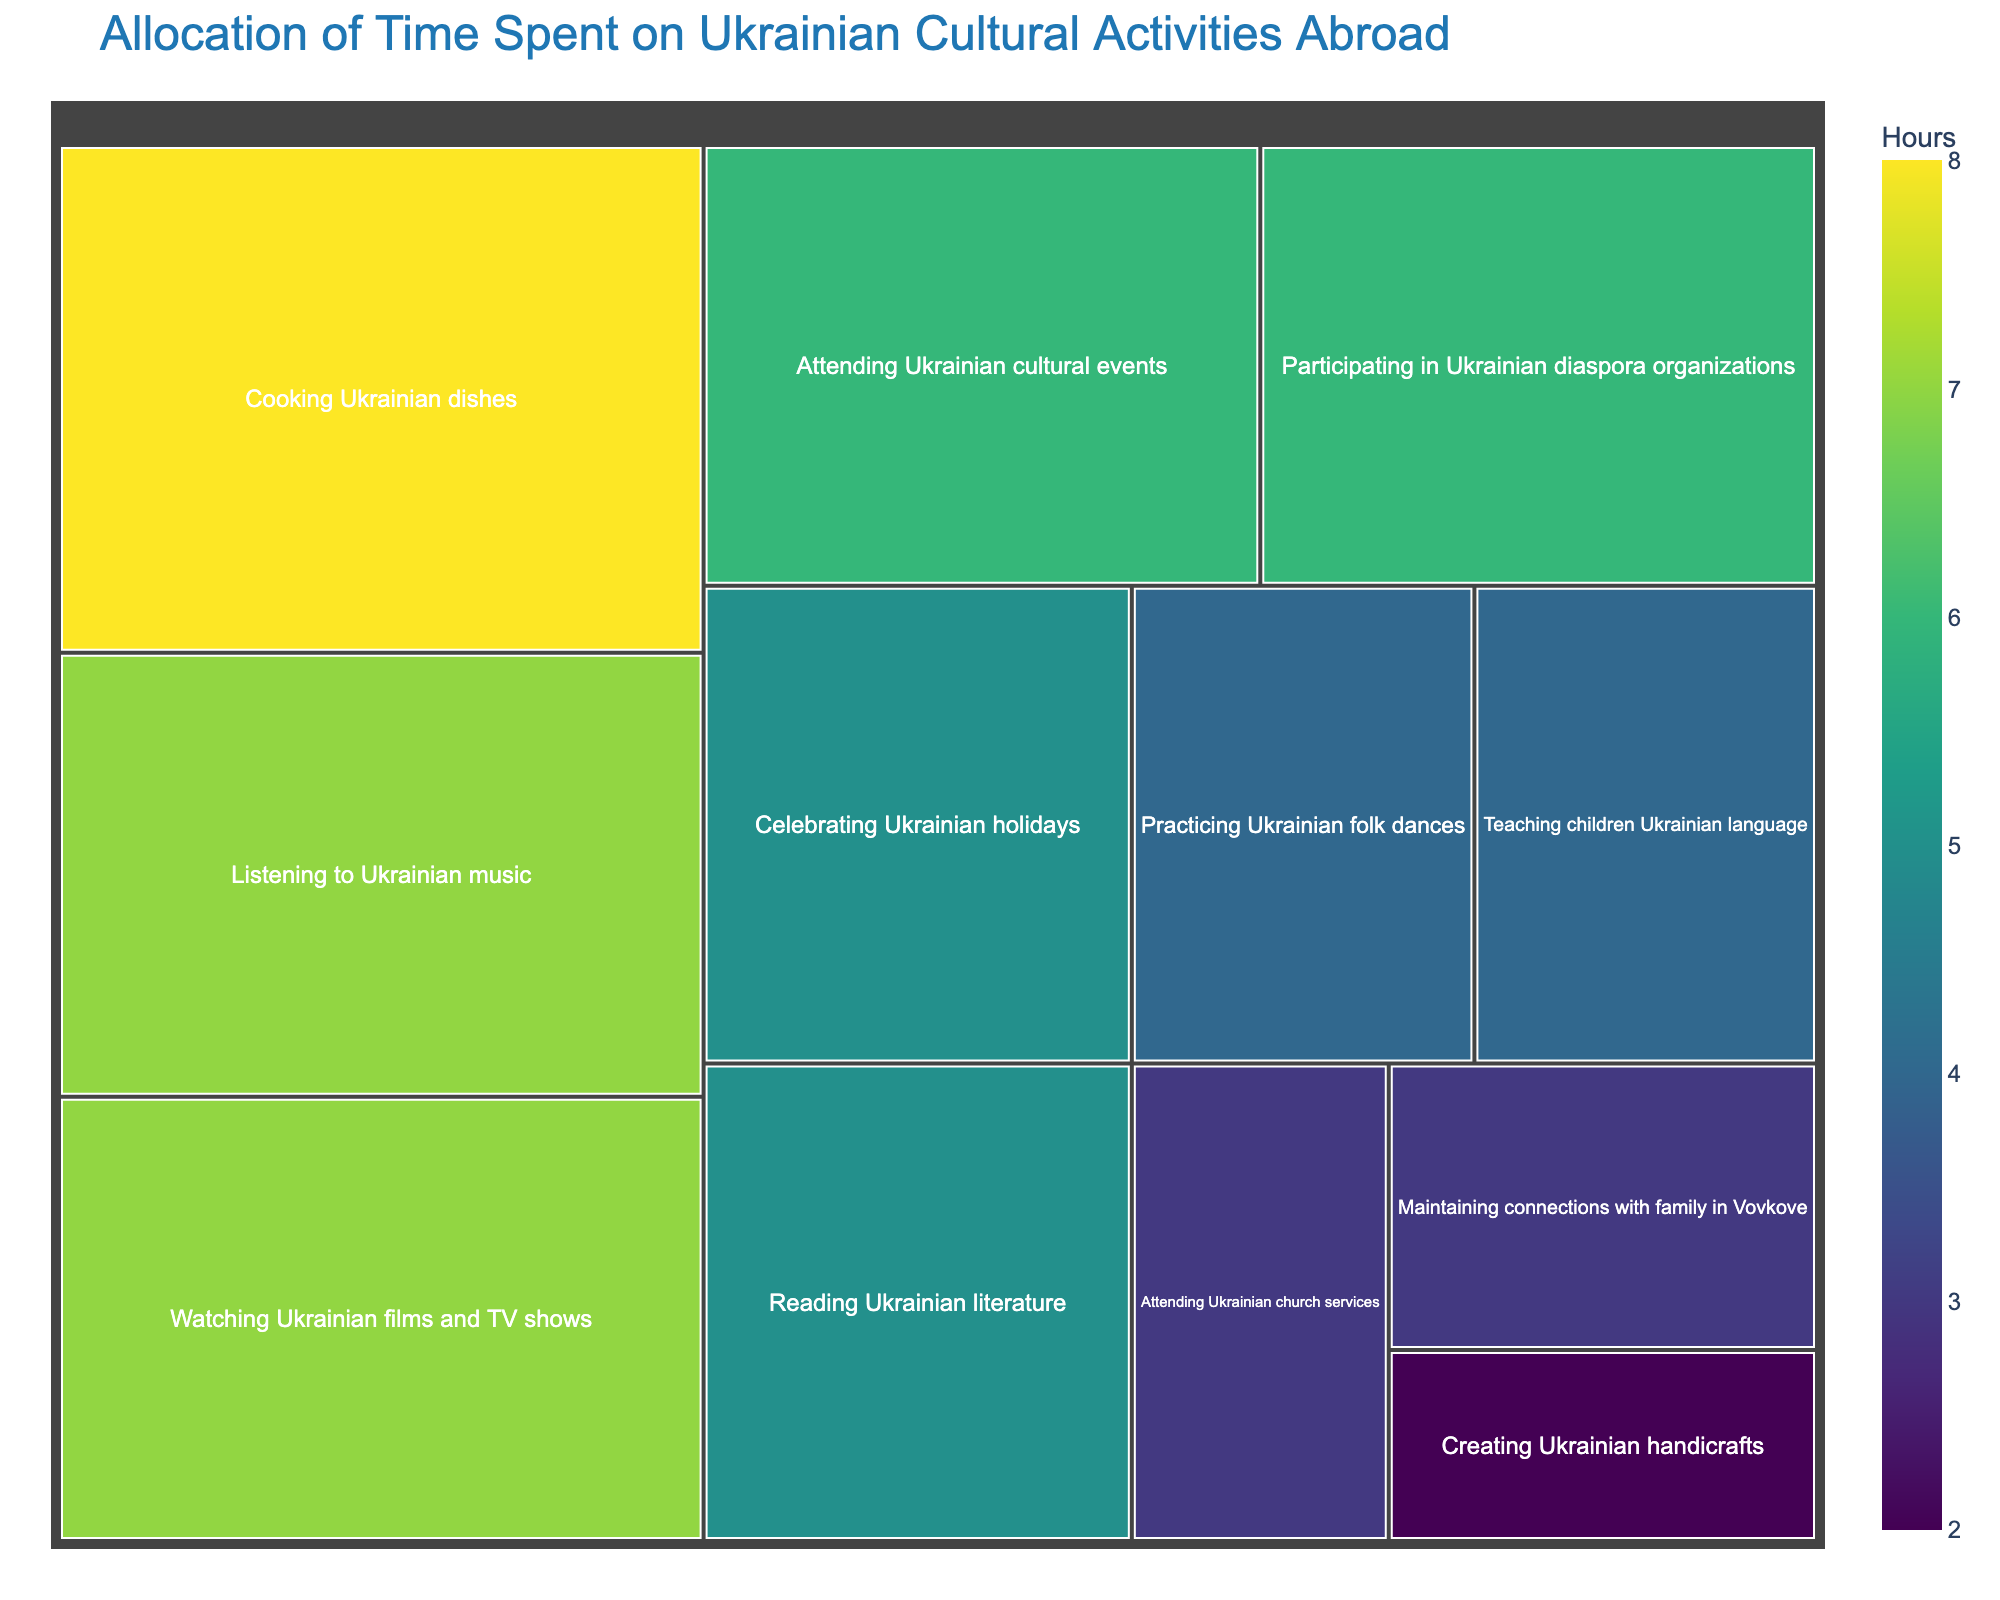What's the title of the figure? The title is usually displayed prominently at the top of the figure. In this treemap, it's labeled clearly.
Answer: Allocation of Time Spent on Ukrainian Cultural Activities Abroad Which activity consumes the most hours? To determine which activity consumes the most hours, look for the largest block in the treemap. The block with "Cooking Ukrainian dishes" is the largest, indicating 8 hours.
Answer: Cooking Ukrainian dishes What is the combined time spent on watching Ukrainian films and TV shows, and listening to Ukrainian music? Add the hours for "Watching Ukrainian films and TV shows" and "Listening to Ukrainian music." The values are 7 hours each. So, 7 + 7 = 14 hours.
Answer: 14 hours Which two activities have the same amount of allocated time? Identify blocks with identical sizes. "Attending Ukrainian cultural events" and "Participating in Ukrainian diaspora organizations" each have 6 hours.
Answer: Attending Ukrainian cultural events and Participating in Ukrainian diaspora organizations How many hours are allocated to maintaining connections with family in Vovkove? Find the block labeled "Maintaining connections with family in Vovkove" to see its allocated hours. It is 3 hours.
Answer: 3 hours By how much does the time spent on teaching children Ukrainian language differ from that on creating Ukrainian handicrafts? Subtract the hours for "Creating Ukrainian handicrafts" from those for "Teaching children Ukrainian language." The values are 4 and 2 respectively: 4 - 2 = 2.
Answer: 2 hours Which activity takes more time, celebrating Ukrainian holidays or attending Ukrainian cultural events? Compare the blocks labeled "Celebrating Ukrainian holidays" and "Attending Ukrainian cultural events." "Celebrating Ukrainian holidays" is 5 hours, while "Attending Ukrainian cultural events" is 6 hours.
Answer: Attending Ukrainian cultural events What is the difference in time spent on the least and most time-consuming activities? Identify the smallest and largest blocks: "Creating Ukrainian handicrafts" (2 hours) and "Cooking Ukrainian dishes" (8 hours). Subtract the smallest from the largest: 8 - 2 = 6.
Answer: 6 hours Which activity takes up the smallest amount of time? Look for the smallest block in the treemap. The smallest block is "Creating Ukrainian handicrafts," which takes up 2 hours.
Answer: Creating Ukrainian handicrafts How much time in total is dedicated to cultural activities that involve some form of media (e.g., watching films, listening to music)? Add the hours for "Watching Ukrainian films and TV shows" (7 hours) and "Listening to Ukrainian music" (7 hours): 7 + 7 = 14 total hours.
Answer: 14 hours 